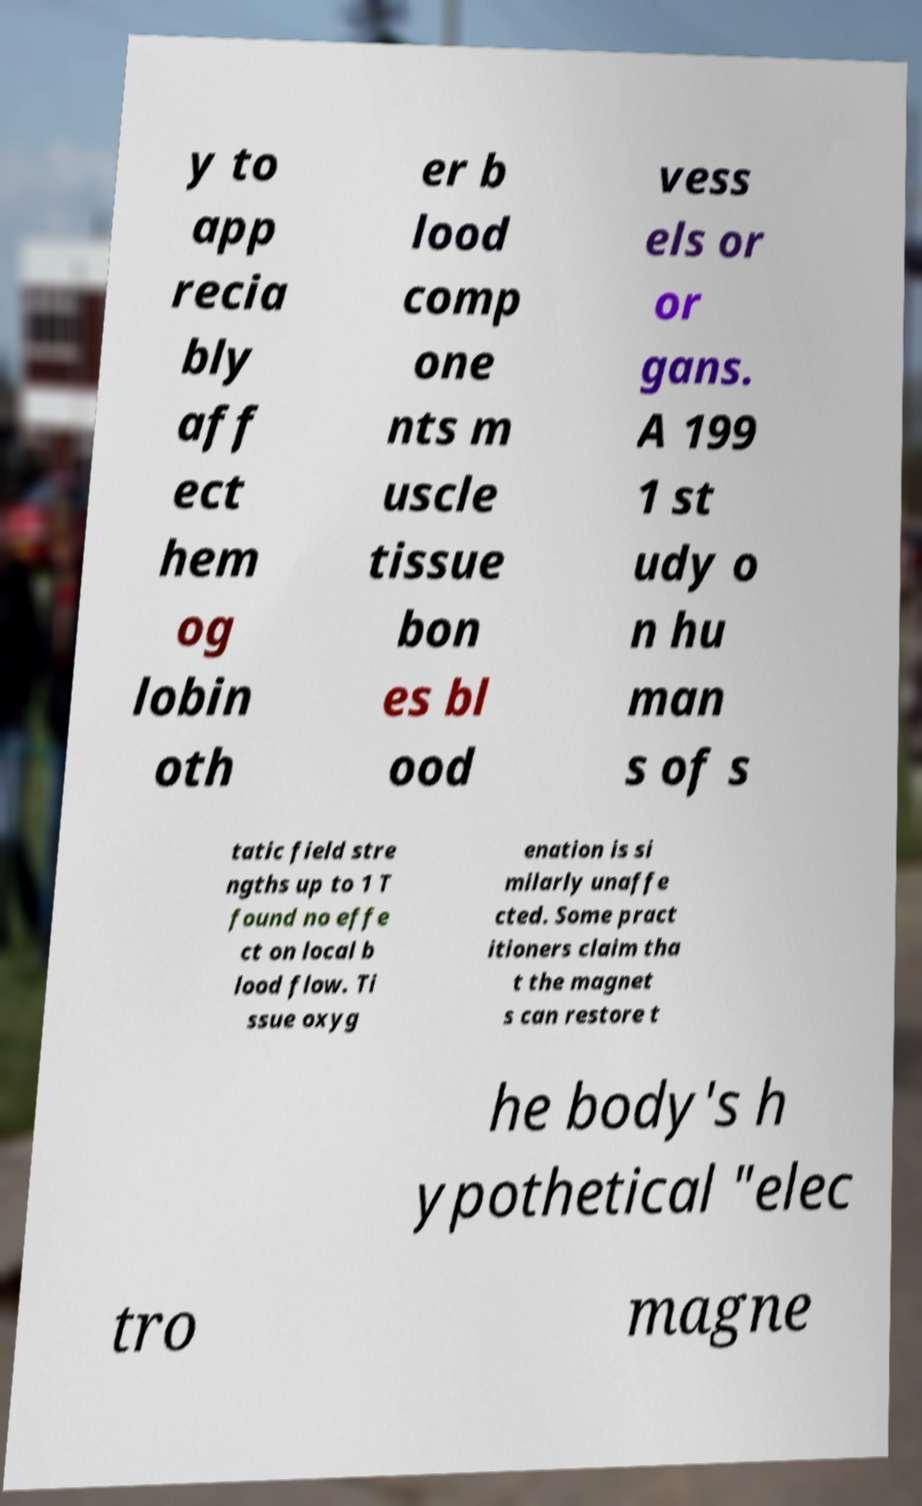Could you extract and type out the text from this image? y to app recia bly aff ect hem og lobin oth er b lood comp one nts m uscle tissue bon es bl ood vess els or or gans. A 199 1 st udy o n hu man s of s tatic field stre ngths up to 1 T found no effe ct on local b lood flow. Ti ssue oxyg enation is si milarly unaffe cted. Some pract itioners claim tha t the magnet s can restore t he body's h ypothetical "elec tro magne 